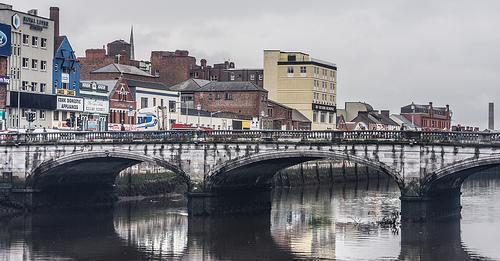How many bridges?
Give a very brief answer. 1. 